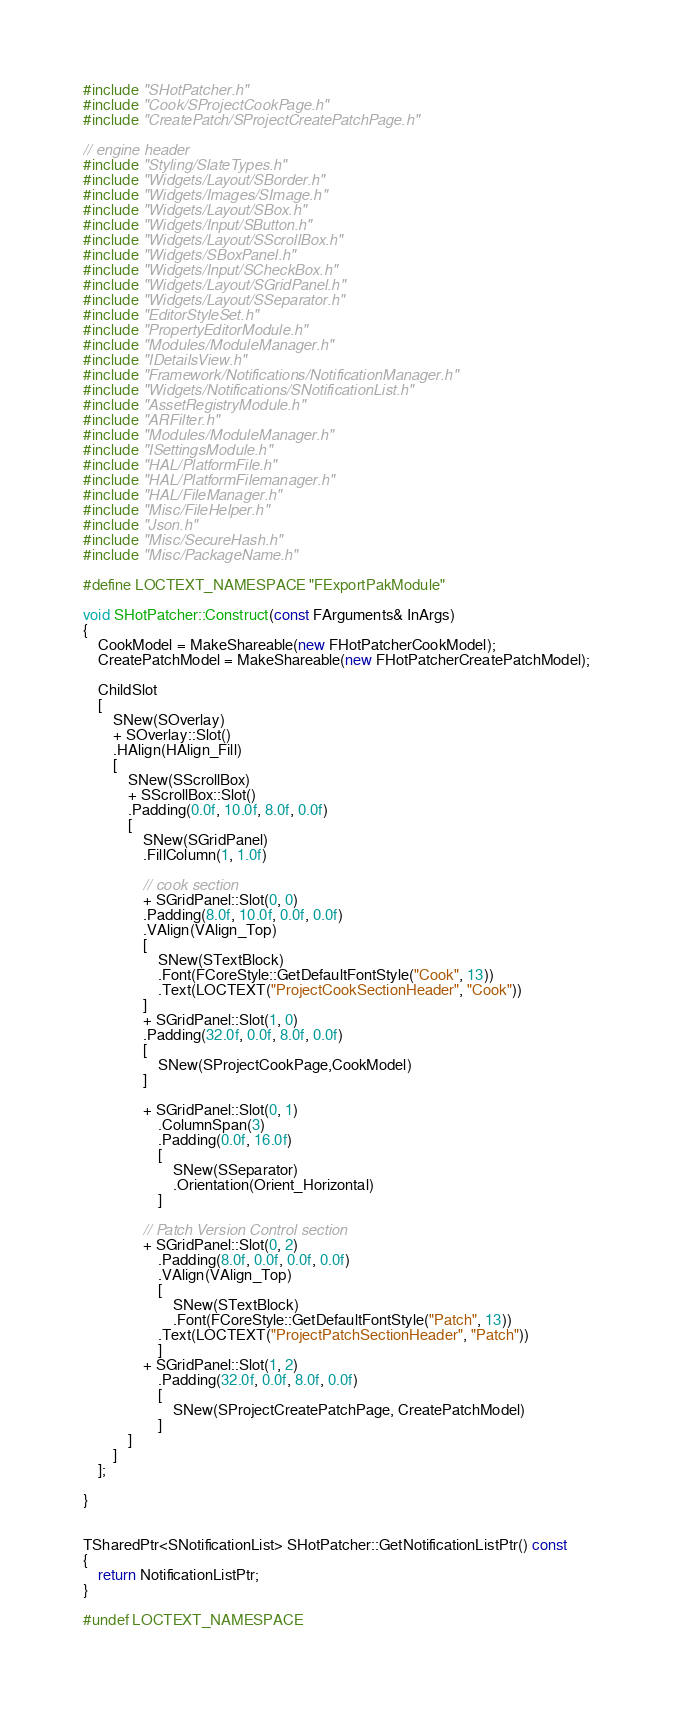<code> <loc_0><loc_0><loc_500><loc_500><_C++_>#include "SHotPatcher.h"
#include "Cook/SProjectCookPage.h"
#include "CreatePatch/SProjectCreatePatchPage.h"

// engine header
#include "Styling/SlateTypes.h"
#include "Widgets/Layout/SBorder.h"
#include "Widgets/Images/SImage.h"
#include "Widgets/Layout/SBox.h"
#include "Widgets/Input/SButton.h"
#include "Widgets/Layout/SScrollBox.h"
#include "Widgets/SBoxPanel.h"
#include "Widgets/Input/SCheckBox.h"
#include "Widgets/Layout/SGridPanel.h"
#include "Widgets/Layout/SSeparator.h"
#include "EditorStyleSet.h"
#include "PropertyEditorModule.h"
#include "Modules/ModuleManager.h"
#include "IDetailsView.h"
#include "Framework/Notifications/NotificationManager.h"
#include "Widgets/Notifications/SNotificationList.h"
#include "AssetRegistryModule.h"
#include "ARFilter.h"
#include "Modules/ModuleManager.h"
#include "ISettingsModule.h"
#include "HAL/PlatformFile.h"
#include "HAL/PlatformFilemanager.h"
#include "HAL/FileManager.h"
#include "Misc/FileHelper.h"
#include "Json.h"
#include "Misc/SecureHash.h"
#include "Misc/PackageName.h"

#define LOCTEXT_NAMESPACE "FExportPakModule"

void SHotPatcher::Construct(const FArguments& InArgs)
{
	CookModel = MakeShareable(new FHotPatcherCookModel);
	CreatePatchModel = MakeShareable(new FHotPatcherCreatePatchModel);

	ChildSlot
	[
		SNew(SOverlay)
		+ SOverlay::Slot()
		.HAlign(HAlign_Fill)
		[
			SNew(SScrollBox)
			+ SScrollBox::Slot()
			.Padding(0.0f, 10.0f, 8.0f, 0.0f)
			[
				SNew(SGridPanel)
				.FillColumn(1, 1.0f)

				// cook section
				+ SGridPanel::Slot(0, 0)
				.Padding(8.0f, 10.0f, 0.0f, 0.0f)
				.VAlign(VAlign_Top)
				[
					SNew(STextBlock)
					.Font(FCoreStyle::GetDefaultFontStyle("Cook", 13))
					.Text(LOCTEXT("ProjectCookSectionHeader", "Cook"))
				]
				+ SGridPanel::Slot(1, 0)
				.Padding(32.0f, 0.0f, 8.0f, 0.0f)
				[
					SNew(SProjectCookPage,CookModel)
				]

				+ SGridPanel::Slot(0, 1)
					.ColumnSpan(3)
					.Padding(0.0f, 16.0f)
					[
						SNew(SSeparator)
						.Orientation(Orient_Horizontal)
					]

				// Patch Version Control section
				+ SGridPanel::Slot(0, 2)
					.Padding(8.0f, 0.0f, 0.0f, 0.0f)
					.VAlign(VAlign_Top)
					[
						SNew(STextBlock)
						.Font(FCoreStyle::GetDefaultFontStyle("Patch", 13))
					.Text(LOCTEXT("ProjectPatchSectionHeader", "Patch"))
					]
				+ SGridPanel::Slot(1, 2)
					.Padding(32.0f, 0.0f, 8.0f, 0.0f)
					[
						SNew(SProjectCreatePatchPage, CreatePatchModel)
					]
			]
		]
	];

}


TSharedPtr<SNotificationList> SHotPatcher::GetNotificationListPtr() const
{
	return NotificationListPtr;
}

#undef LOCTEXT_NAMESPACE</code> 